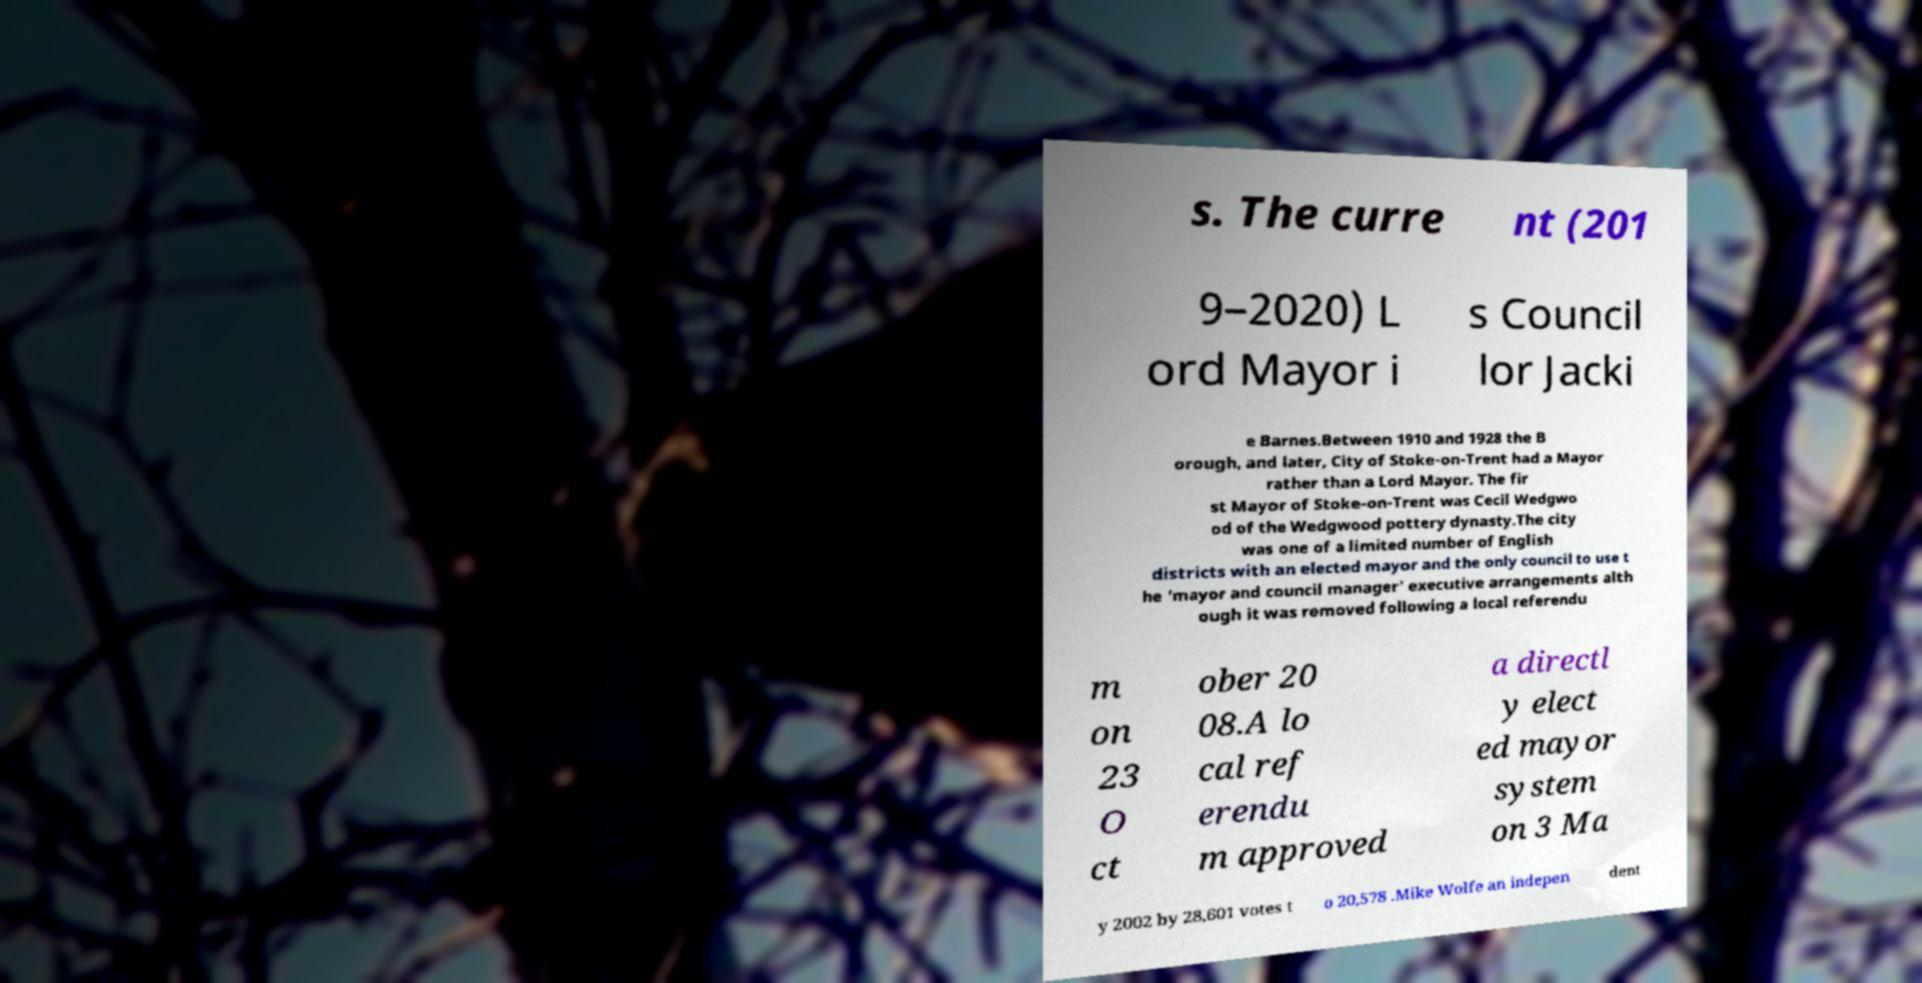Can you read and provide the text displayed in the image?This photo seems to have some interesting text. Can you extract and type it out for me? s. The curre nt (201 9–2020) L ord Mayor i s Council lor Jacki e Barnes.Between 1910 and 1928 the B orough, and later, City of Stoke-on-Trent had a Mayor rather than a Lord Mayor. The fir st Mayor of Stoke-on-Trent was Cecil Wedgwo od of the Wedgwood pottery dynasty.The city was one of a limited number of English districts with an elected mayor and the only council to use t he 'mayor and council manager' executive arrangements alth ough it was removed following a local referendu m on 23 O ct ober 20 08.A lo cal ref erendu m approved a directl y elect ed mayor system on 3 Ma y 2002 by 28,601 votes t o 20,578 .Mike Wolfe an indepen dent 